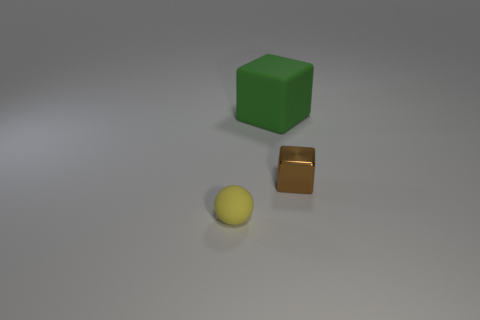Is there any other thing that has the same size as the green thing?
Provide a succinct answer. No. What shape is the object that is made of the same material as the tiny yellow ball?
Your answer should be very brief. Cube. What material is the small object that is to the right of the rubber thing that is in front of the matte thing to the right of the small matte ball?
Your response must be concise. Metal. There is a green cube; is its size the same as the rubber thing that is in front of the big rubber block?
Give a very brief answer. No. There is another big green thing that is the same shape as the metallic thing; what material is it?
Your response must be concise. Rubber. There is a rubber object in front of the block right of the matte object to the right of the tiny rubber thing; how big is it?
Keep it short and to the point. Small. Is the size of the yellow ball the same as the brown metal block?
Your response must be concise. Yes. There is a small thing that is on the left side of the tiny object that is on the right side of the tiny matte thing; what is its material?
Your answer should be compact. Rubber. There is a rubber thing on the right side of the tiny matte sphere; is it the same shape as the tiny thing right of the small sphere?
Give a very brief answer. Yes. Are there an equal number of small yellow matte things behind the tiny yellow rubber ball and tiny cyan rubber objects?
Make the answer very short. Yes. 